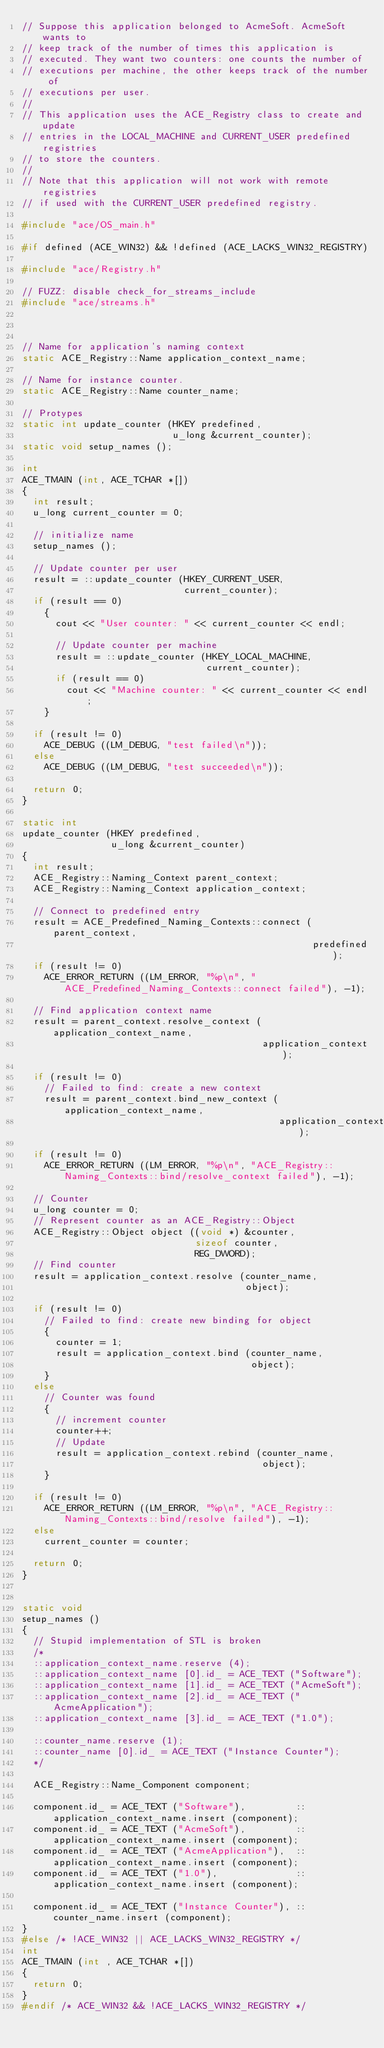<code> <loc_0><loc_0><loc_500><loc_500><_C++_>// Suppose this application belonged to AcmeSoft. AcmeSoft wants to
// keep track of the number of times this application is
// executed. They want two counters: one counts the number of
// executions per machine, the other keeps track of the number of
// executions per user.
//
// This application uses the ACE_Registry class to create and update
// entries in the LOCAL_MACHINE and CURRENT_USER predefined registries
// to store the counters.
//
// Note that this application will not work with remote registries
// if used with the CURRENT_USER predefined registry.

#include "ace/OS_main.h"

#if defined (ACE_WIN32) && !defined (ACE_LACKS_WIN32_REGISTRY)

#include "ace/Registry.h"

// FUZZ: disable check_for_streams_include
#include "ace/streams.h"



// Name for application's naming context
static ACE_Registry::Name application_context_name;

// Name for instance counter.
static ACE_Registry::Name counter_name;

// Protypes
static int update_counter (HKEY predefined,
                           u_long &current_counter);
static void setup_names ();

int
ACE_TMAIN (int, ACE_TCHAR *[])
{
  int result;
  u_long current_counter = 0;

  // initialize name
  setup_names ();

  // Update counter per user
  result = ::update_counter (HKEY_CURRENT_USER,
                             current_counter);
  if (result == 0)
    {
      cout << "User counter: " << current_counter << endl;

      // Update counter per machine
      result = ::update_counter (HKEY_LOCAL_MACHINE,
                                 current_counter);
      if (result == 0)
        cout << "Machine counter: " << current_counter << endl;
    }

  if (result != 0)
    ACE_DEBUG ((LM_DEBUG, "test failed\n"));
  else
    ACE_DEBUG ((LM_DEBUG, "test succeeded\n"));

  return 0;
}

static int
update_counter (HKEY predefined,
                u_long &current_counter)
{
  int result;
  ACE_Registry::Naming_Context parent_context;
  ACE_Registry::Naming_Context application_context;

  // Connect to predefined entry
  result = ACE_Predefined_Naming_Contexts::connect (parent_context,
                                                    predefined);
  if (result != 0)
    ACE_ERROR_RETURN ((LM_ERROR, "%p\n", "ACE_Predefined_Naming_Contexts::connect failed"), -1);

  // Find application context name
  result = parent_context.resolve_context (application_context_name,
                                           application_context);

  if (result != 0)
    // Failed to find: create a new context
    result = parent_context.bind_new_context (application_context_name,
                                              application_context);

  if (result != 0)
    ACE_ERROR_RETURN ((LM_ERROR, "%p\n", "ACE_Registry::Naming_Contexts::bind/resolve_context failed"), -1);

  // Counter
  u_long counter = 0;
  // Represent counter as an ACE_Registry::Object
  ACE_Registry::Object object ((void *) &counter,
                               sizeof counter,
                               REG_DWORD);
  // Find counter
  result = application_context.resolve (counter_name,
                                        object);

  if (result != 0)
    // Failed to find: create new binding for object
    {
      counter = 1;
      result = application_context.bind (counter_name,
                                         object);
    }
  else
    // Counter was found
    {
      // increment counter
      counter++;
      // Update
      result = application_context.rebind (counter_name,
                                           object);
    }

  if (result != 0)
    ACE_ERROR_RETURN ((LM_ERROR, "%p\n", "ACE_Registry::Naming_Contexts::bind/resolve failed"), -1);
  else
    current_counter = counter;

  return 0;
}


static void
setup_names ()
{
  // Stupid implementation of STL is broken
  /*
  ::application_context_name.reserve (4);
  ::application_context_name [0].id_ = ACE_TEXT ("Software");
  ::application_context_name [1].id_ = ACE_TEXT ("AcmeSoft");
  ::application_context_name [2].id_ = ACE_TEXT ("AcmeApplication");
  ::application_context_name [3].id_ = ACE_TEXT ("1.0");

  ::counter_name.reserve (1);
  ::counter_name [0].id_ = ACE_TEXT ("Instance Counter");
  */

  ACE_Registry::Name_Component component;

  component.id_ = ACE_TEXT ("Software"),         ::application_context_name.insert (component);
  component.id_ = ACE_TEXT ("AcmeSoft"),         ::application_context_name.insert (component);
  component.id_ = ACE_TEXT ("AcmeApplication"),  ::application_context_name.insert (component);
  component.id_ = ACE_TEXT ("1.0"),              ::application_context_name.insert (component);

  component.id_ = ACE_TEXT ("Instance Counter"), ::counter_name.insert (component);
}
#else /* !ACE_WIN32 || ACE_LACKS_WIN32_REGISTRY */
int
ACE_TMAIN (int , ACE_TCHAR *[])
{
  return 0;
}
#endif /* ACE_WIN32 && !ACE_LACKS_WIN32_REGISTRY */
</code> 